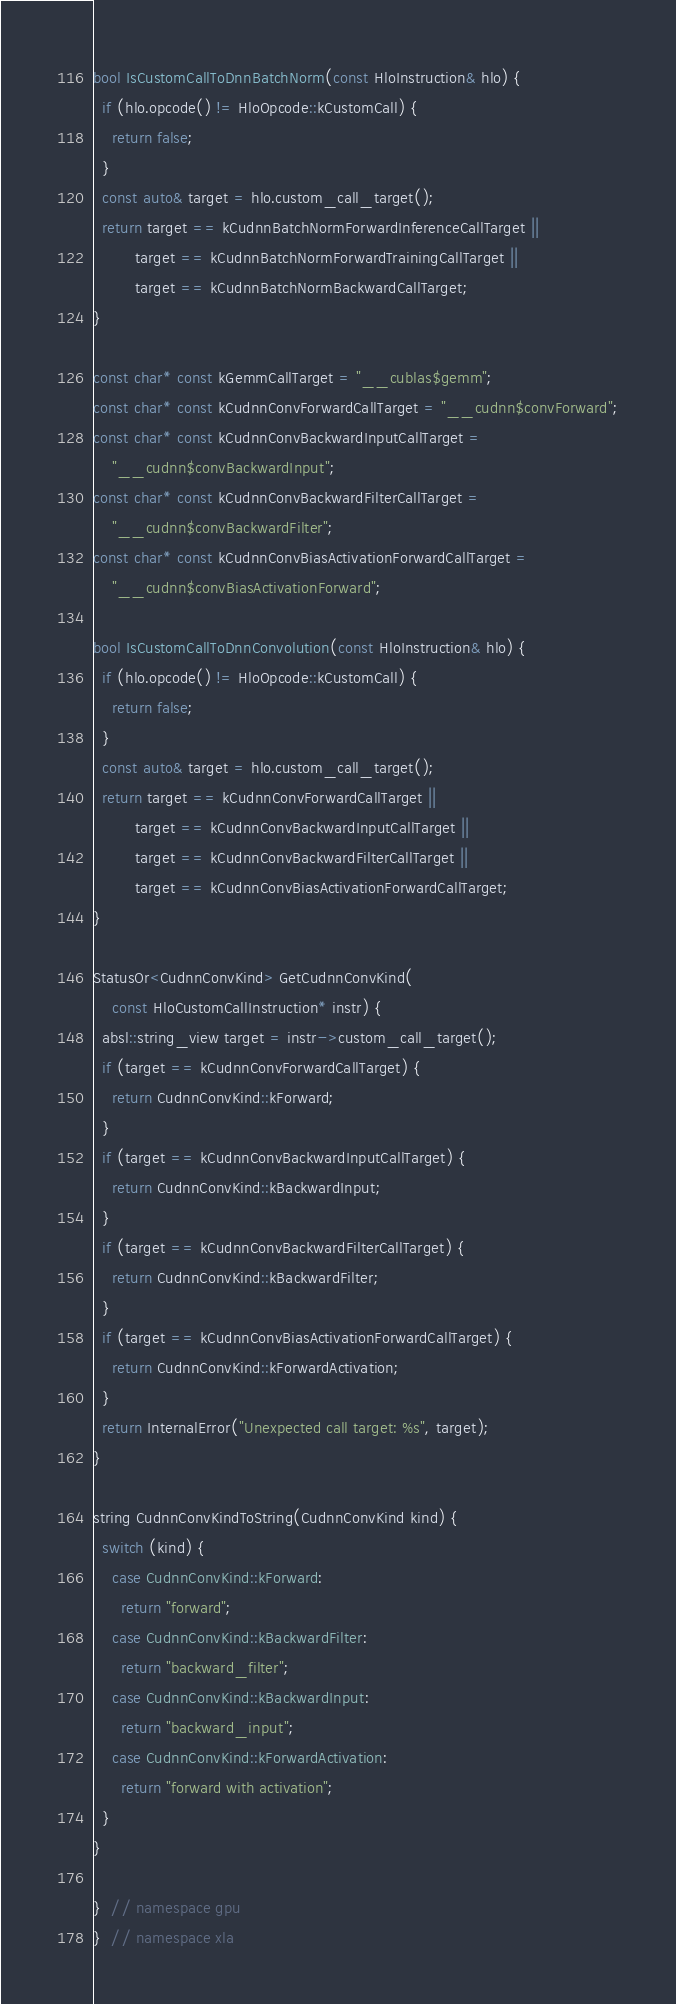Convert code to text. <code><loc_0><loc_0><loc_500><loc_500><_C++_>bool IsCustomCallToDnnBatchNorm(const HloInstruction& hlo) {
  if (hlo.opcode() != HloOpcode::kCustomCall) {
    return false;
  }
  const auto& target = hlo.custom_call_target();
  return target == kCudnnBatchNormForwardInferenceCallTarget ||
         target == kCudnnBatchNormForwardTrainingCallTarget ||
         target == kCudnnBatchNormBackwardCallTarget;
}

const char* const kGemmCallTarget = "__cublas$gemm";
const char* const kCudnnConvForwardCallTarget = "__cudnn$convForward";
const char* const kCudnnConvBackwardInputCallTarget =
    "__cudnn$convBackwardInput";
const char* const kCudnnConvBackwardFilterCallTarget =
    "__cudnn$convBackwardFilter";
const char* const kCudnnConvBiasActivationForwardCallTarget =
    "__cudnn$convBiasActivationForward";

bool IsCustomCallToDnnConvolution(const HloInstruction& hlo) {
  if (hlo.opcode() != HloOpcode::kCustomCall) {
    return false;
  }
  const auto& target = hlo.custom_call_target();
  return target == kCudnnConvForwardCallTarget ||
         target == kCudnnConvBackwardInputCallTarget ||
         target == kCudnnConvBackwardFilterCallTarget ||
         target == kCudnnConvBiasActivationForwardCallTarget;
}

StatusOr<CudnnConvKind> GetCudnnConvKind(
    const HloCustomCallInstruction* instr) {
  absl::string_view target = instr->custom_call_target();
  if (target == kCudnnConvForwardCallTarget) {
    return CudnnConvKind::kForward;
  }
  if (target == kCudnnConvBackwardInputCallTarget) {
    return CudnnConvKind::kBackwardInput;
  }
  if (target == kCudnnConvBackwardFilterCallTarget) {
    return CudnnConvKind::kBackwardFilter;
  }
  if (target == kCudnnConvBiasActivationForwardCallTarget) {
    return CudnnConvKind::kForwardActivation;
  }
  return InternalError("Unexpected call target: %s", target);
}

string CudnnConvKindToString(CudnnConvKind kind) {
  switch (kind) {
    case CudnnConvKind::kForward:
      return "forward";
    case CudnnConvKind::kBackwardFilter:
      return "backward_filter";
    case CudnnConvKind::kBackwardInput:
      return "backward_input";
    case CudnnConvKind::kForwardActivation:
      return "forward with activation";
  }
}

}  // namespace gpu
}  // namespace xla
</code> 